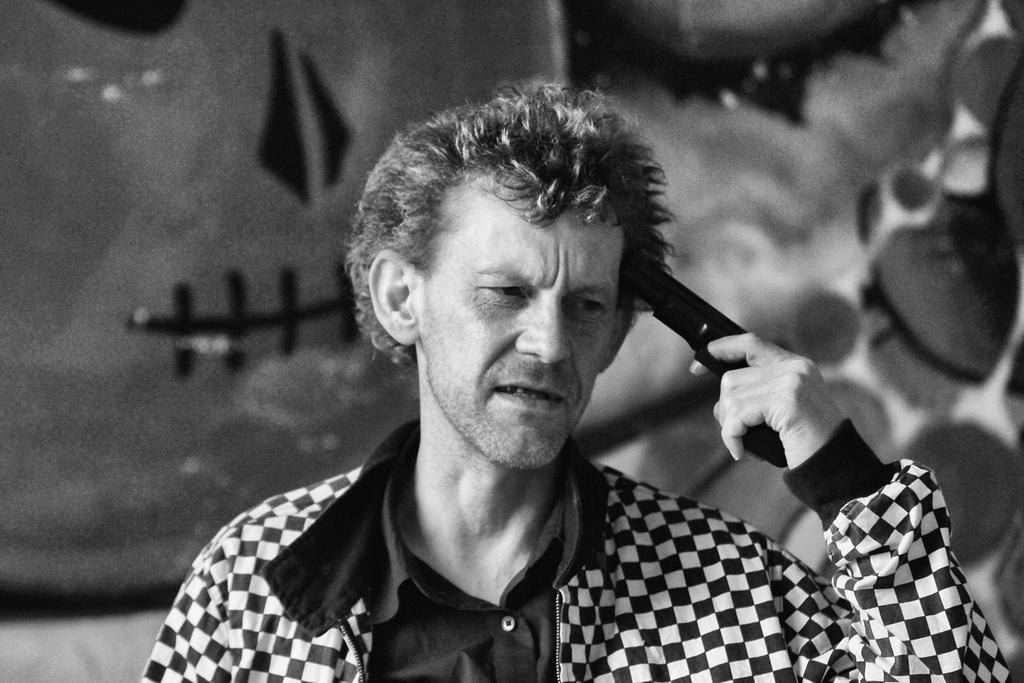Can you describe this image briefly? In the foreground of this image, there is a man standing, wearing a coat and holding a gun and the background image is not clear. 